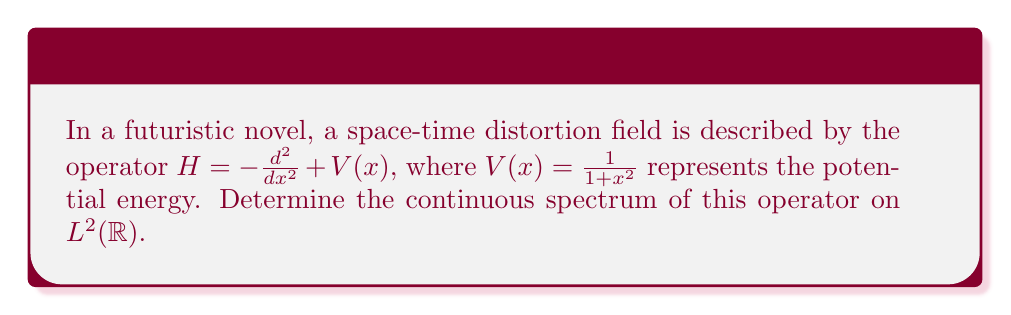Could you help me with this problem? To evaluate the continuous spectrum of the operator $H$, we follow these steps:

1) First, recall that for Schrödinger operators of the form $H = -\frac{d^2}{dx^2} + V(x)$ on $L^2(\mathbb{R})$, the continuous spectrum is typically $[\inf V, \infty)$ if $V(x)$ vanishes at infinity.

2) In our case, $V(x) = \frac{1}{1+x^2}$. Let's examine its behavior:

   $$\lim_{|x| \to \infty} V(x) = \lim_{|x| \to \infty} \frac{1}{1+x^2} = 0$$

3) This potential indeed vanishes at infinity, so we expect the continuous spectrum to be $[0,\infty)$.

4) To find $\inf V$, we analyze $V(x)$:
   
   $$V'(x) = -\frac{2x}{(1+x^2)^2} = 0 \iff x = 0$$

   The global minimum occurs at $x = 0$, where $V(0) = 1$.

5) Therefore, the continuous spectrum is $[\inf V, \infty) = [0, \infty)$.

6) This result can be rigorously proved using Weyl's criterion, which states that $\lambda$ is in the continuous spectrum if and only if there exists a sequence of unit vectors $\{u_n\}$ in the domain of $H$ such that $\|(H-\lambda I)u_n\| \to 0$ as $n \to \infty$.
Answer: $[0,\infty)$ 